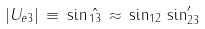<formula> <loc_0><loc_0><loc_500><loc_500>| U _ { e 3 } | \, \equiv \, \sin \hat { _ { 1 3 } } \, \approx \, \sin _ { 1 2 } \, \sin ^ { \prime } _ { 2 3 }</formula> 